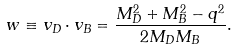<formula> <loc_0><loc_0><loc_500><loc_500>w \equiv v _ { D } \cdot v _ { B } = \frac { M _ { D } ^ { 2 } + M _ { B } ^ { 2 } - q ^ { 2 } } { 2 M _ { D } M _ { B } } .</formula> 